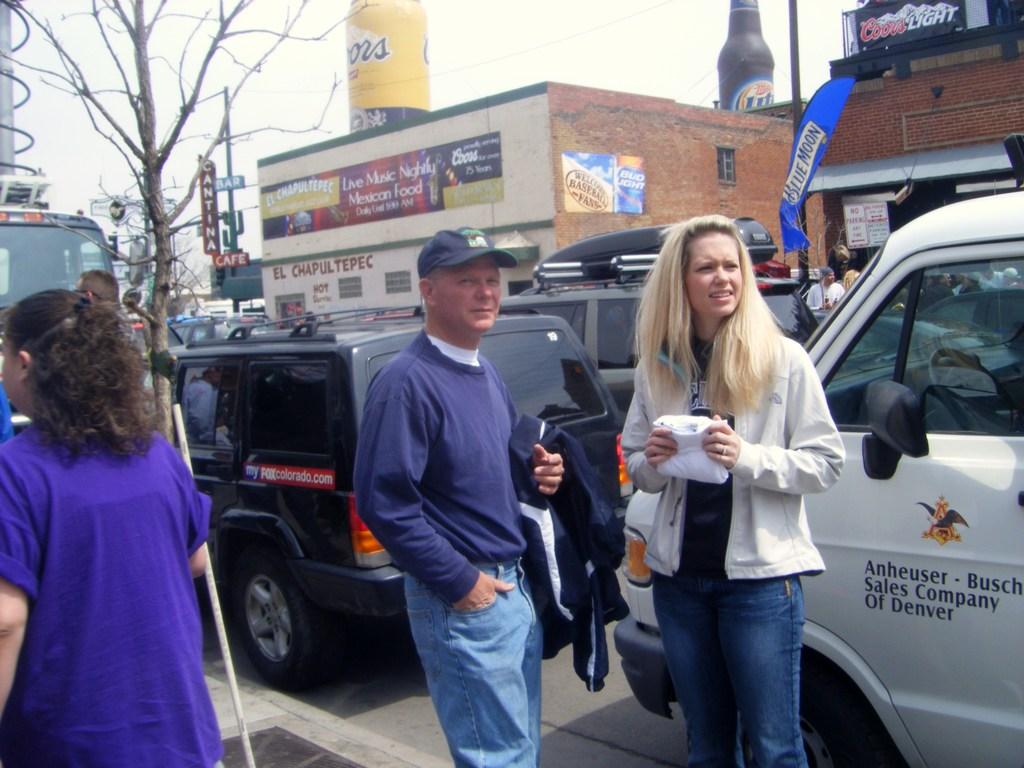What brand of beer is on the van?
Provide a short and direct response. Anheuser-busch. 